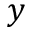Convert formula to latex. <formula><loc_0><loc_0><loc_500><loc_500>y</formula> 